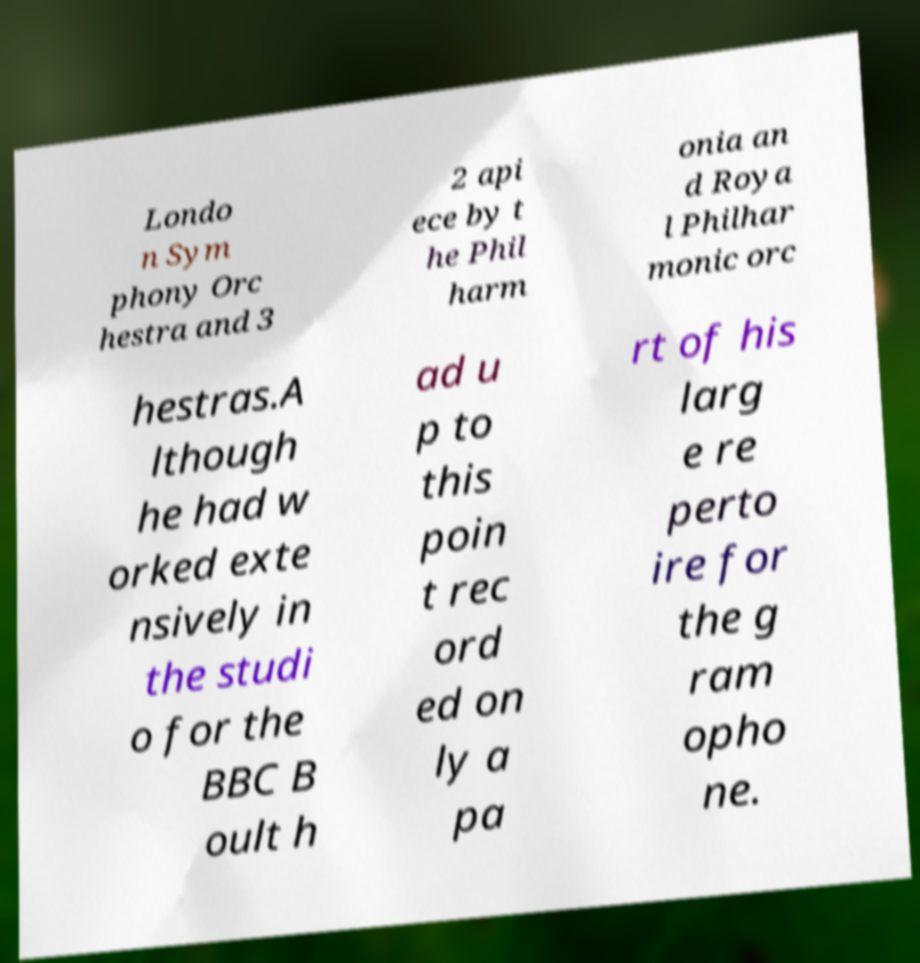I need the written content from this picture converted into text. Can you do that? Londo n Sym phony Orc hestra and 3 2 api ece by t he Phil harm onia an d Roya l Philhar monic orc hestras.A lthough he had w orked exte nsively in the studi o for the BBC B oult h ad u p to this poin t rec ord ed on ly a pa rt of his larg e re perto ire for the g ram opho ne. 